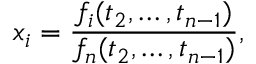Convert formula to latex. <formula><loc_0><loc_0><loc_500><loc_500>x _ { i } = { \frac { f _ { i } ( t _ { 2 } , \dots , t _ { n - 1 } ) } { f _ { n } ( t _ { 2 } , \dots , t _ { n - 1 } ) } } ,</formula> 